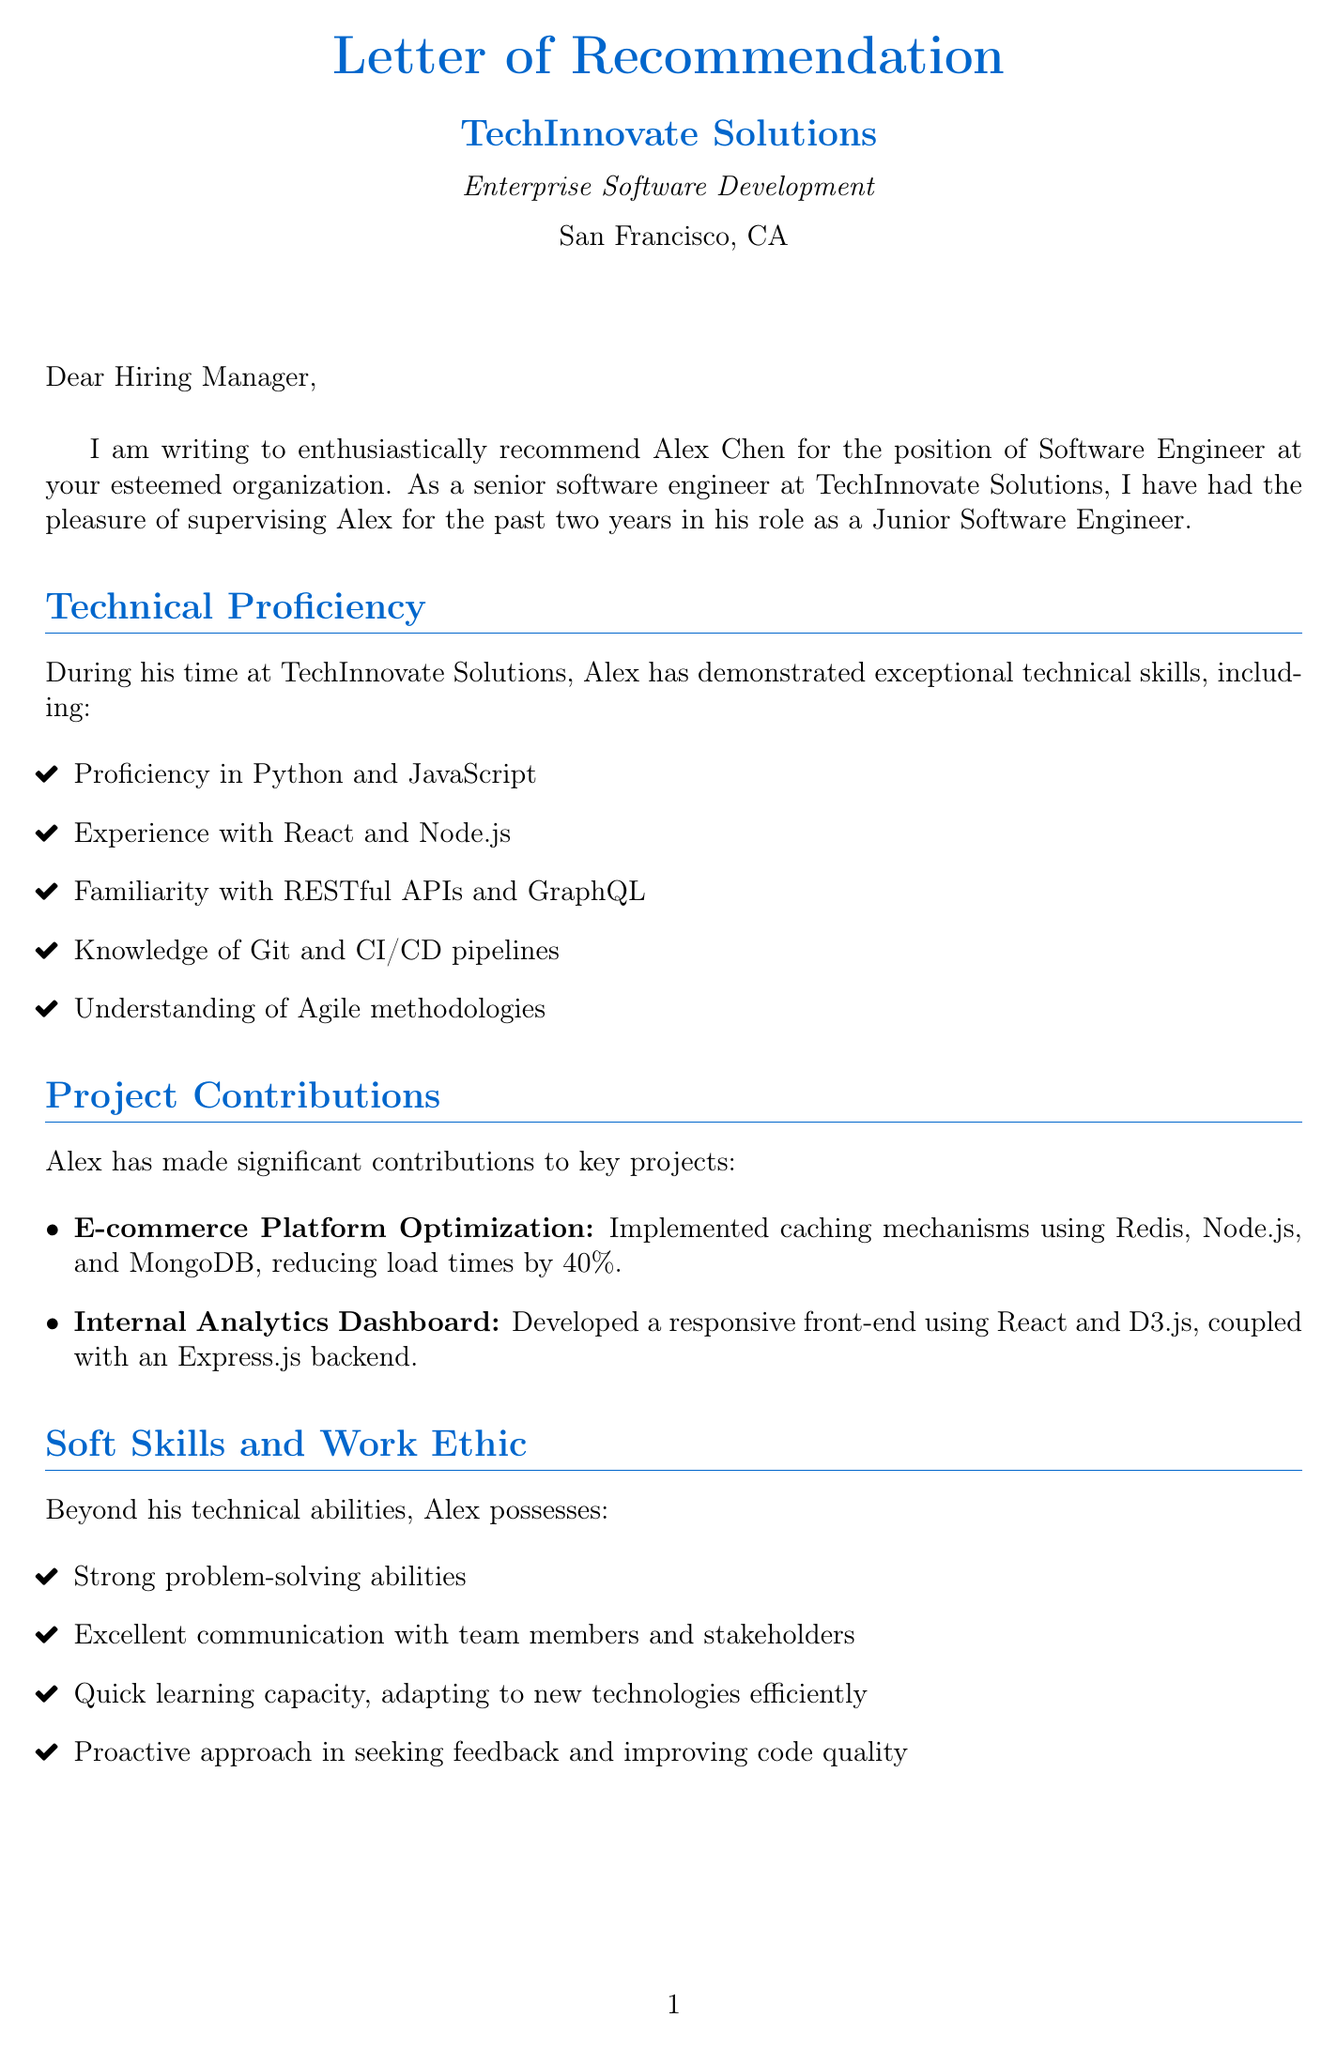What is the name of the junior engineer being recommended? The name of the junior engineer is mentioned at the beginning of the letter.
Answer: Alex Chen How many years of experience does Alex have? The letter states Alex has two years of experience at TechInnovate Solutions.
Answer: 2 What programming languages is Alex proficient in? Alex's proficiency in programming languages is listed under technical skills in the document.
Answer: Python and JavaScript What was one of Alex's contributions to the E-commerce Platform Optimization project? The document details Alex's contribution to the project in a specific manner.
Answer: Implemented caching mechanisms, reducing load times by 40% What role did Alex demonstrate potential for? The document highlights specific potential roles Alex could transition into in the future.
Answer: Lead small to medium-sized development teams What soft skill emphasizes Alex's adaptability? The letter discusses Alex's ability to learn and adapt quickly in a section on soft skills.
Answer: Quick learner, adapting to new technologies efficiently Who is the author of the letter? The author's title and organization are mentioned at the conclusion of the letter.
Answer: Senior Software Engineer What is the industry of TechInnovate Solutions? The industry is specified early on in the document.
Answer: Enterprise Software Development What is one of Alex's notable achievements? The letter lists several notable achievements, focusing on specific aspects of Alex's work.
Answer: Optimized database queries, reducing API response times by 60% 